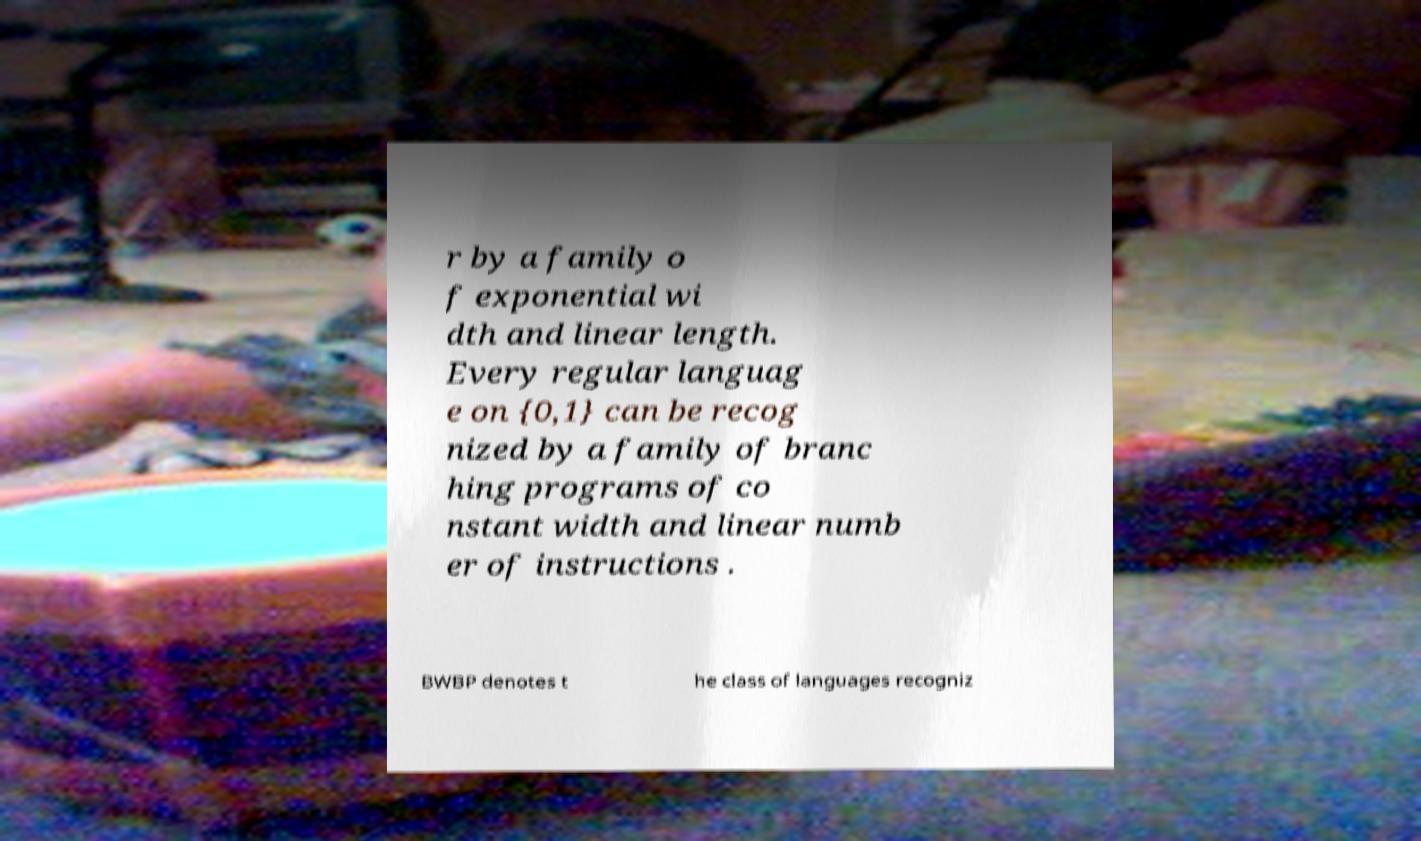Please identify and transcribe the text found in this image. r by a family o f exponential wi dth and linear length. Every regular languag e on {0,1} can be recog nized by a family of branc hing programs of co nstant width and linear numb er of instructions . BWBP denotes t he class of languages recogniz 